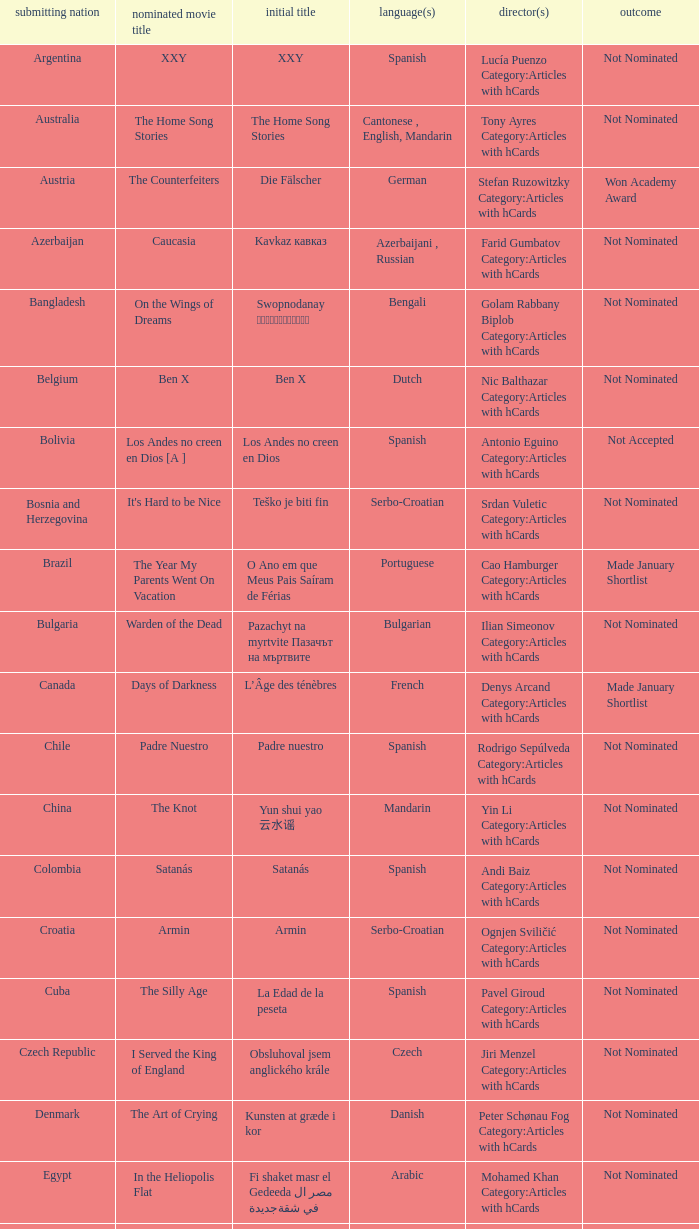What was the title of the movie from lebanon? Caramel. 